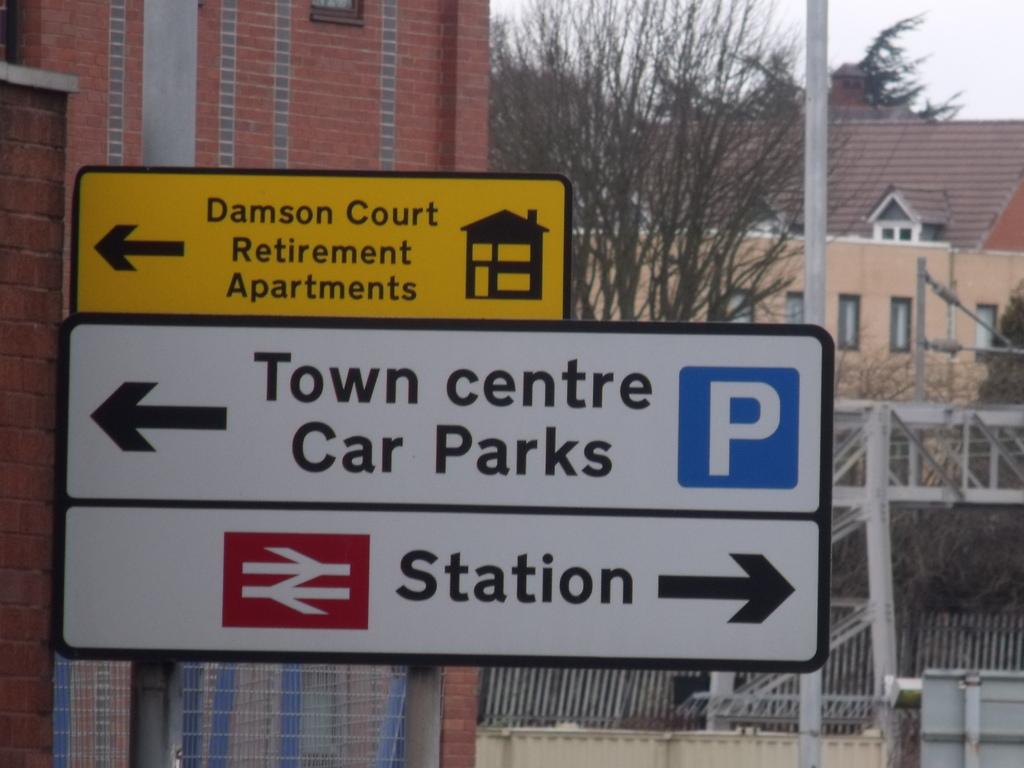What is to the right?
Provide a short and direct response. Station. Where is damson court?
Provide a succinct answer. To the left. 